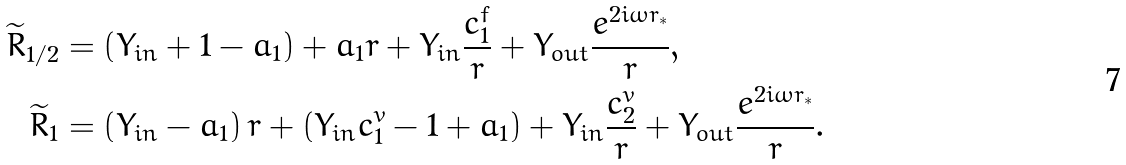<formula> <loc_0><loc_0><loc_500><loc_500>\widetilde { R } _ { 1 / 2 } & = \left ( Y _ { i n } + 1 - a _ { 1 } \right ) + a _ { 1 } r + Y _ { i n } \frac { c ^ { f } _ { 1 } } { r } + Y _ { o u t } \frac { e ^ { 2 i \omega r _ { * } } } { r } , \\ \widetilde { R } _ { 1 } & = \left ( Y _ { i n } - a _ { 1 } \right ) r + \left ( Y _ { i n } c ^ { v } _ { 1 } - 1 + a _ { 1 } \right ) + Y _ { i n } \frac { c ^ { v } _ { 2 } } { r } + Y _ { o u t } \frac { e ^ { 2 i \omega r _ { * } } } { r } .</formula> 